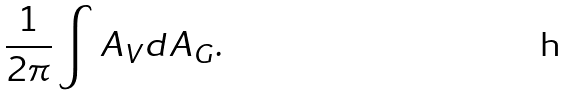Convert formula to latex. <formula><loc_0><loc_0><loc_500><loc_500>\frac { 1 } { 2 \pi } \int A _ { V } d A _ { G } .</formula> 